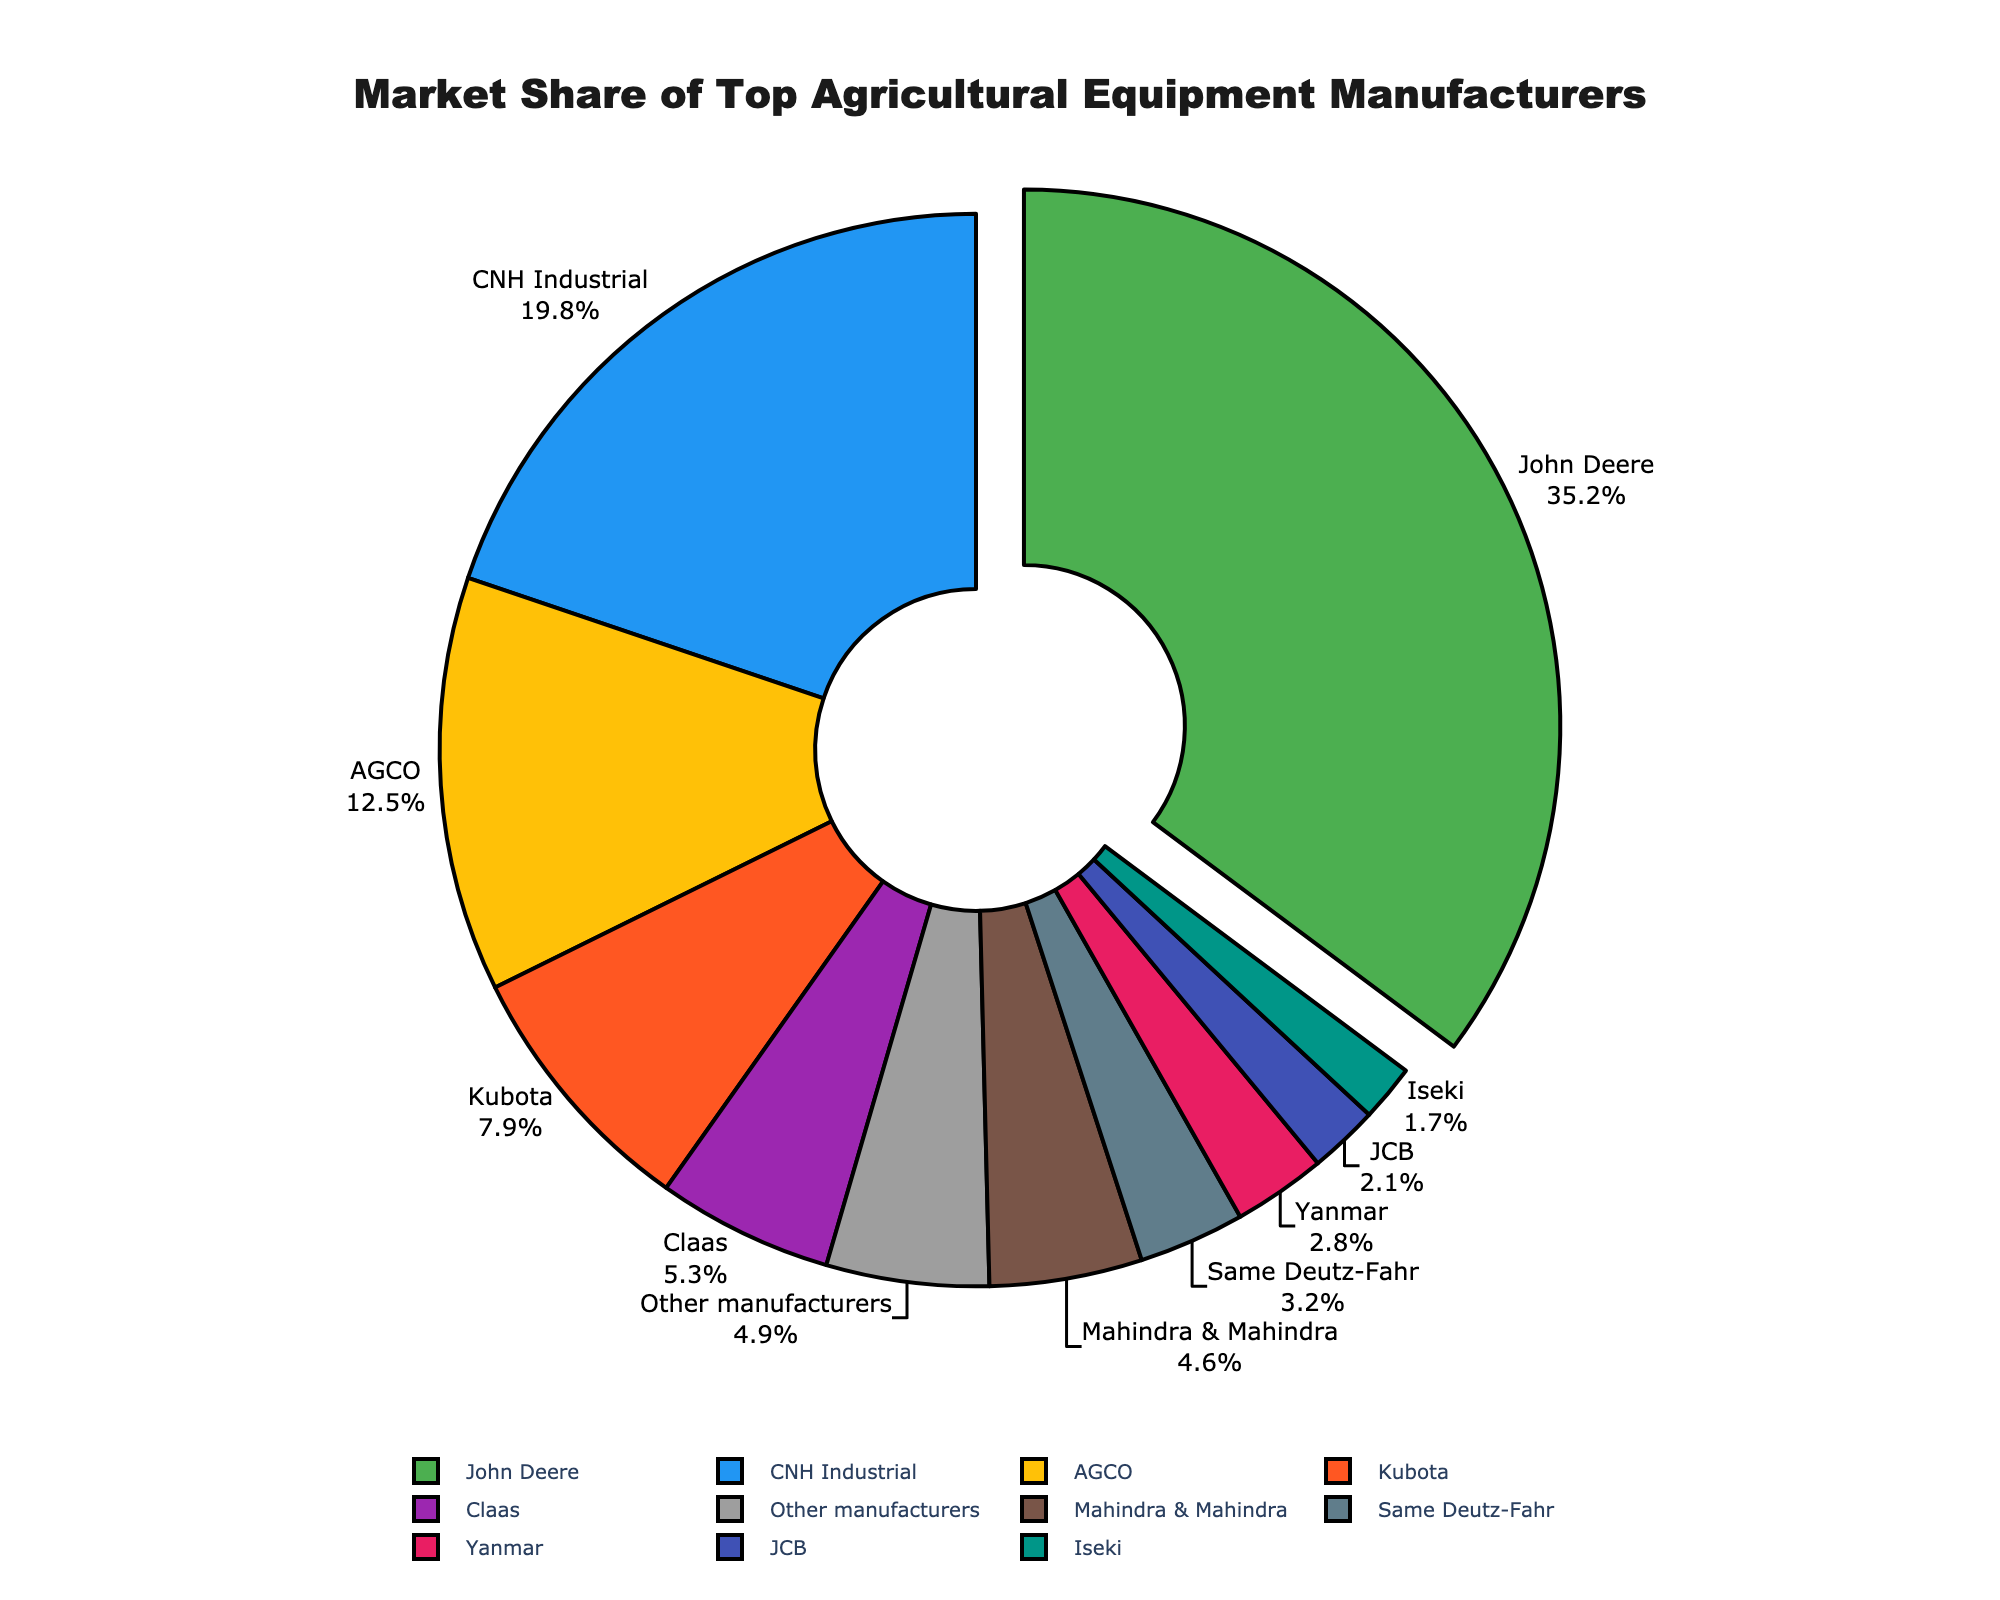What’s the combined market share of John Deere and CNH Industrial? To find the combined market share, add the market share percentages of John Deere and CNH Industrial. John Deere has 35.2% and CNH Industrial has 19.8%. So, the combined market share is 35.2 + 19.8 = 55%.
Answer: 55% What is the difference in market share between John Deere and AGCO? To find the difference, subtract the market share of AGCO from that of John Deere. John Deere has 35.2% and AGCO has 12.5%. The difference is 35.2 - 12.5 = 22.7%.
Answer: 22.7% Which manufacturer has a larger market share, Kubota or Claas? To determine which has a larger market share, compare the percentages. Kubota has 7.9% and Claas has 5.3%. Since 7.9% is greater than 5.3%, Kubota has a larger market share.
Answer: Kubota What color represents John Deere in the pie chart? The pie chart is colored, and the specific segment for John Deere is typically highlighted with a pull-out effect or is in the color green.
Answer: Green How much larger is the market share of John Deere compared to Mahindra & Mahindra? Subtract the market share of Mahindra & Mahindra from that of John Deere. John Deere has 35.2% and Mahindra & Mahindra has 4.6%. The difference is 35.2 - 4.6 = 30.6%.
Answer: 30.6% Which manufacturer’s market share is represented by the color blue in the pie chart? In the provided color scheme, the manufacturer with a blue segment is CNH Industrial.
Answer: CNH Industrial What is the total market share of manufacturers with less than 5% each? Sum up the market shares of Claas, Mahindra & Mahindra, Same Deutz-Fahr, Yanmar, JCB, and Iseki, which are all below 5%. So, the total is 5.3 + 4.6 + 3.2 + 2.8 + 2.1 + 1.7 = 19.7%.
Answer: 19.7% Which manufacturer has the smallest market share, and what is it? To identify the smallest share, compare all the given percentages. Iseki has the smallest market share with 1.7%.
Answer: Iseki, 1.7% What is the average market share of the top three manufacturers? Add the market shares of the top three manufacturers (John Deere, CNH Industrial, AGCO) and divide by 3. So, (35.2 + 19.8 + 12.5) / 3 = 67.5 / 3 = 22.5%.
Answer: 22.5% If the market share of "Other manufacturers" increased by 2%, how would that affect their representation in the chart? Adding 2% to the current market share of "Other manufacturers," which is 4.9%, gives 4.9 + 2 = 6.9%. Their representation in the chart would increase accordingly.
Answer: 6.9% 